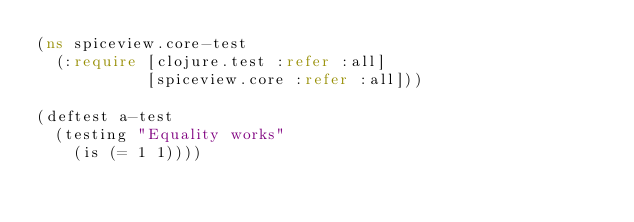<code> <loc_0><loc_0><loc_500><loc_500><_Clojure_>(ns spiceview.core-test
  (:require [clojure.test :refer :all]
            [spiceview.core :refer :all]))

(deftest a-test
  (testing "Equality works"
    (is (= 1 1))))
</code> 